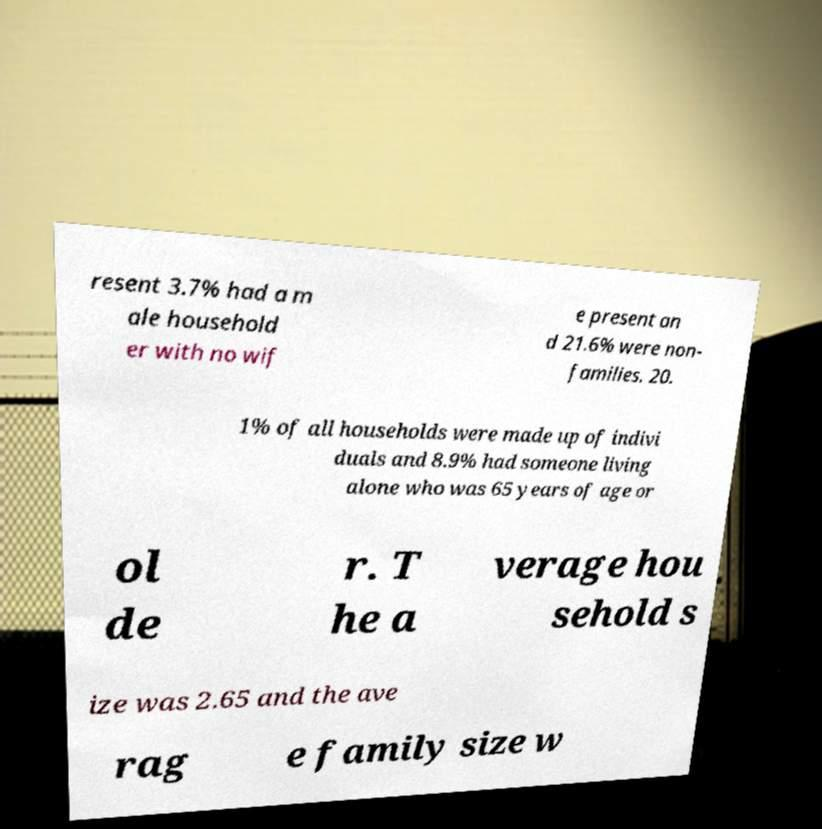Please identify and transcribe the text found in this image. resent 3.7% had a m ale household er with no wif e present an d 21.6% were non- families. 20. 1% of all households were made up of indivi duals and 8.9% had someone living alone who was 65 years of age or ol de r. T he a verage hou sehold s ize was 2.65 and the ave rag e family size w 